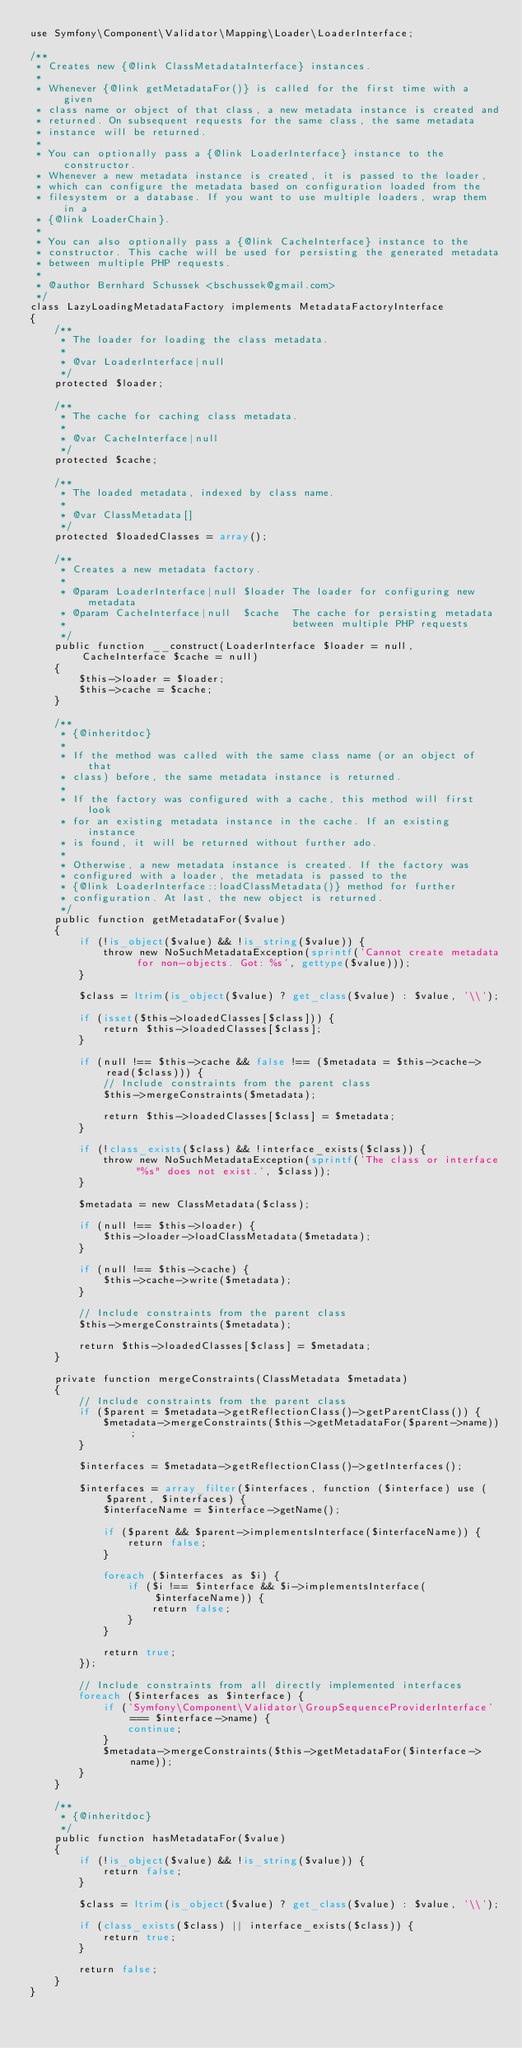<code> <loc_0><loc_0><loc_500><loc_500><_PHP_>use Symfony\Component\Validator\Mapping\Loader\LoaderInterface;

/**
 * Creates new {@link ClassMetadataInterface} instances.
 *
 * Whenever {@link getMetadataFor()} is called for the first time with a given
 * class name or object of that class, a new metadata instance is created and
 * returned. On subsequent requests for the same class, the same metadata
 * instance will be returned.
 *
 * You can optionally pass a {@link LoaderInterface} instance to the constructor.
 * Whenever a new metadata instance is created, it is passed to the loader,
 * which can configure the metadata based on configuration loaded from the
 * filesystem or a database. If you want to use multiple loaders, wrap them in a
 * {@link LoaderChain}.
 *
 * You can also optionally pass a {@link CacheInterface} instance to the
 * constructor. This cache will be used for persisting the generated metadata
 * between multiple PHP requests.
 *
 * @author Bernhard Schussek <bschussek@gmail.com>
 */
class LazyLoadingMetadataFactory implements MetadataFactoryInterface
{
    /**
     * The loader for loading the class metadata.
     *
     * @var LoaderInterface|null
     */
    protected $loader;

    /**
     * The cache for caching class metadata.
     *
     * @var CacheInterface|null
     */
    protected $cache;

    /**
     * The loaded metadata, indexed by class name.
     *
     * @var ClassMetadata[]
     */
    protected $loadedClasses = array();

    /**
     * Creates a new metadata factory.
     *
     * @param LoaderInterface|null $loader The loader for configuring new metadata
     * @param CacheInterface|null  $cache  The cache for persisting metadata
     *                                     between multiple PHP requests
     */
    public function __construct(LoaderInterface $loader = null, CacheInterface $cache = null)
    {
        $this->loader = $loader;
        $this->cache = $cache;
    }

    /**
     * {@inheritdoc}
     *
     * If the method was called with the same class name (or an object of that
     * class) before, the same metadata instance is returned.
     *
     * If the factory was configured with a cache, this method will first look
     * for an existing metadata instance in the cache. If an existing instance
     * is found, it will be returned without further ado.
     *
     * Otherwise, a new metadata instance is created. If the factory was
     * configured with a loader, the metadata is passed to the
     * {@link LoaderInterface::loadClassMetadata()} method for further
     * configuration. At last, the new object is returned.
     */
    public function getMetadataFor($value)
    {
        if (!is_object($value) && !is_string($value)) {
            throw new NoSuchMetadataException(sprintf('Cannot create metadata for non-objects. Got: %s', gettype($value)));
        }

        $class = ltrim(is_object($value) ? get_class($value) : $value, '\\');

        if (isset($this->loadedClasses[$class])) {
            return $this->loadedClasses[$class];
        }

        if (null !== $this->cache && false !== ($metadata = $this->cache->read($class))) {
            // Include constraints from the parent class
            $this->mergeConstraints($metadata);

            return $this->loadedClasses[$class] = $metadata;
        }

        if (!class_exists($class) && !interface_exists($class)) {
            throw new NoSuchMetadataException(sprintf('The class or interface "%s" does not exist.', $class));
        }

        $metadata = new ClassMetadata($class);

        if (null !== $this->loader) {
            $this->loader->loadClassMetadata($metadata);
        }

        if (null !== $this->cache) {
            $this->cache->write($metadata);
        }

        // Include constraints from the parent class
        $this->mergeConstraints($metadata);

        return $this->loadedClasses[$class] = $metadata;
    }

    private function mergeConstraints(ClassMetadata $metadata)
    {
        // Include constraints from the parent class
        if ($parent = $metadata->getReflectionClass()->getParentClass()) {
            $metadata->mergeConstraints($this->getMetadataFor($parent->name));
        }

        $interfaces = $metadata->getReflectionClass()->getInterfaces();

        $interfaces = array_filter($interfaces, function ($interface) use ($parent, $interfaces) {
            $interfaceName = $interface->getName();

            if ($parent && $parent->implementsInterface($interfaceName)) {
                return false;
            }

            foreach ($interfaces as $i) {
                if ($i !== $interface && $i->implementsInterface($interfaceName)) {
                    return false;
                }
            }

            return true;
        });

        // Include constraints from all directly implemented interfaces
        foreach ($interfaces as $interface) {
            if ('Symfony\Component\Validator\GroupSequenceProviderInterface' === $interface->name) {
                continue;
            }
            $metadata->mergeConstraints($this->getMetadataFor($interface->name));
        }
    }

    /**
     * {@inheritdoc}
     */
    public function hasMetadataFor($value)
    {
        if (!is_object($value) && !is_string($value)) {
            return false;
        }

        $class = ltrim(is_object($value) ? get_class($value) : $value, '\\');

        if (class_exists($class) || interface_exists($class)) {
            return true;
        }

        return false;
    }
}
</code> 